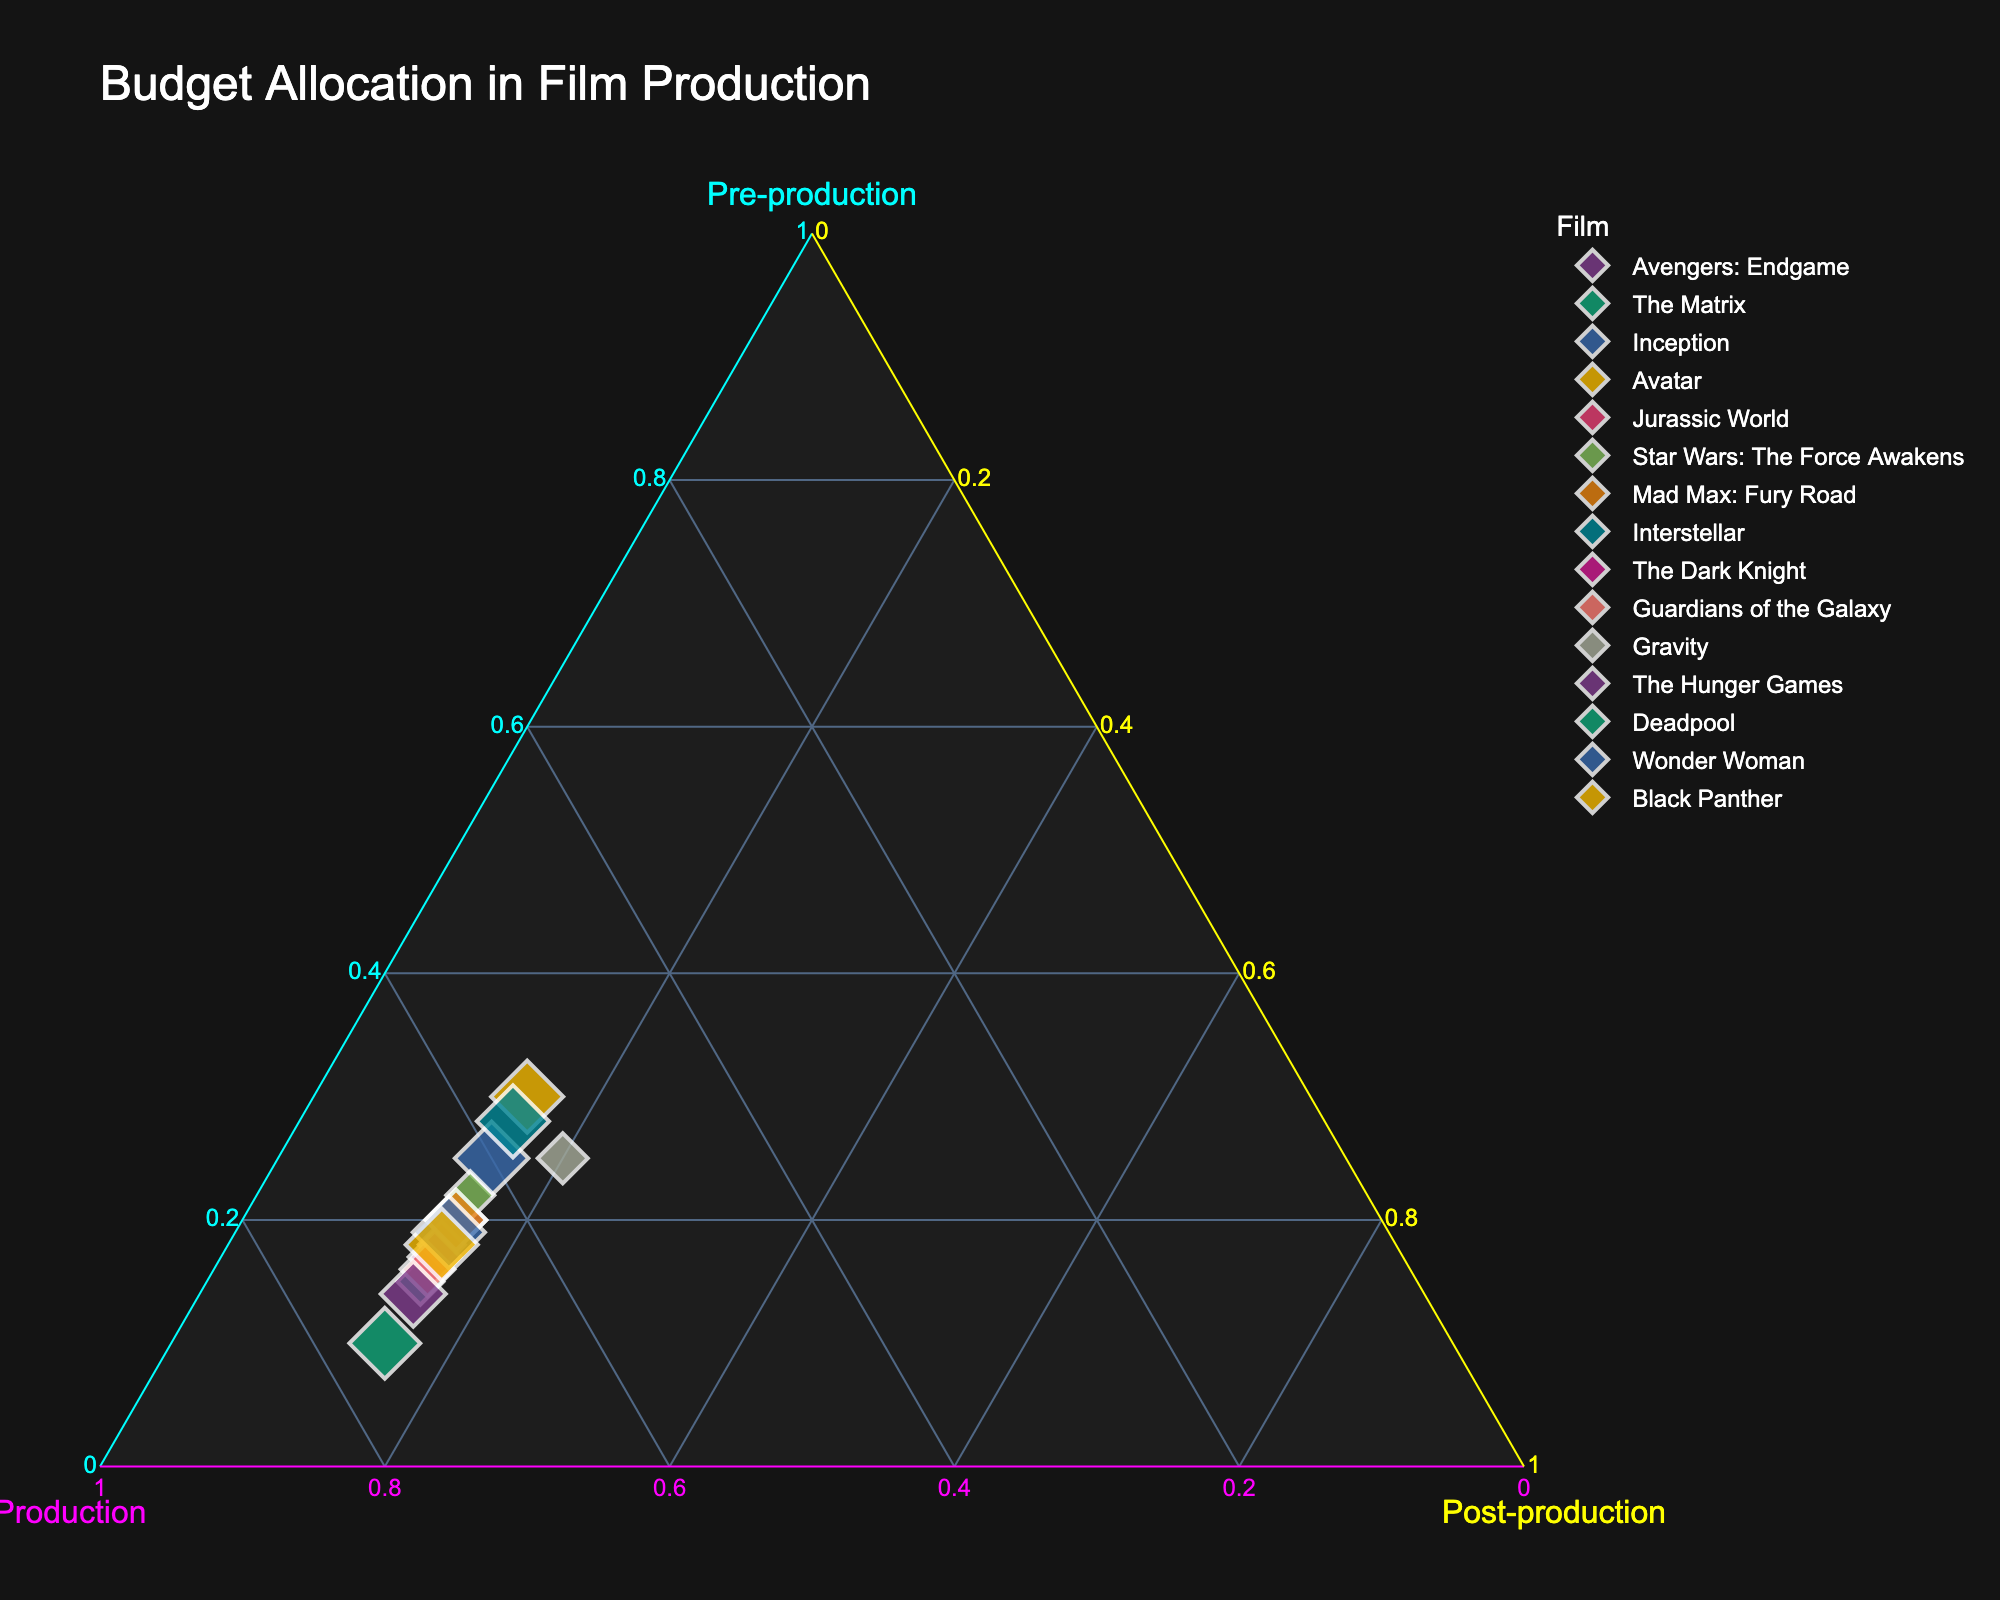What is the title of the ternary plot? The title of a plot is usually clearly displayed at the top. In this case, it reads "Budget Allocation in Film Production".
Answer: Budget Allocation in Film Production Which film has the largest proportion of its budget allocated to pre-production? By observing the ternary plot, we look for the point furthest along the Pre-production axis. This corresponds to "Avatar", which has the highest pre-production budget allocation of 30%.
Answer: Avatar How many films have equal proportions of their budgets allocated to production and post-production? By checking the data points in the plot, we identify that many films have a budget allocation of 70% to production and 15% to post-production. So, the total count of such films is determined by counting these points. There are 10 such films.
Answer: 10 Which film allocates the highest percentage of its budget to production? From the plot, we search for the point located farthest along the Production axis. The point representing "Deadpool" sits at 75%, the highest allocation in production.
Answer: Deadpool Which films have the same budget allocation pattern? By checking points that overlap each other in the ternary plot, we see that "Avengers: Endgame", "Mad Max: Fury Road", "Star Wars: The Force Awakens", and "Wonder Woman" allocate 20% to pre-production, 65% to production, and 15% to post-production.
Answer: Avengers: Endgame, Mad Max: Fury Road, Star Wars: The Force Awakens, Wonder Woman What is the median value of pre-production budget allocation among the films? By sorting the pre-production values: 10, 14, 15, 15, 16, 17, 18, 18, 19, 20, 20, 22, 25, 25, 28, 30; the median is the middle value. With 15 data points, the middle values are the 8th and 9th values, both 18.
Answer: 18 Which film has a higher proportion allocated to post-production than production? By identifying points where the post-production percentage is higher than the production percentage, we find none exist as all films have higher production percentages.
Answer: None Compare the budget allocations of "Interstellar" and "Jurassic World". Which film dedicates more to production? "Interstellar" allocates 57% to production while "Jurassic World" allocates 67%. So, "Jurassic World" dedicates more to production.
Answer: Jurassic World What is the average allocation for post-production across all films? Calculate the average by summing all post-production percentages and dividing by the number of films: (15+15+15+15+15+15+15+15+15+15+20+15+15+15+15)/15 = 16.
Answer: 16 Which film has the smallest proportion allocated to pre-production? By inspecting the pre-production values, we see that "Deadpool" has the smallest proportion at 10%.
Answer: Deadpool 